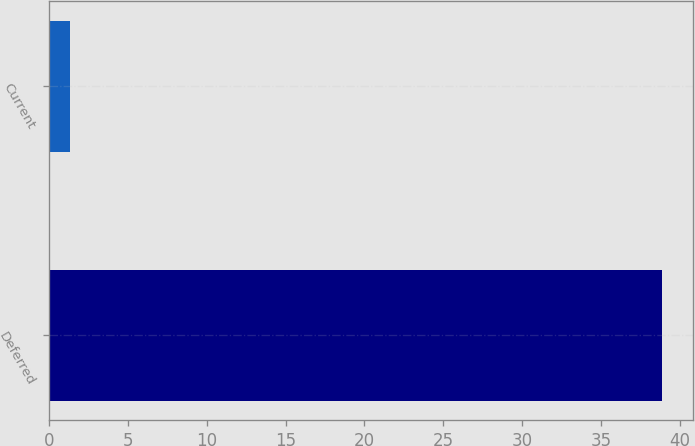Convert chart to OTSL. <chart><loc_0><loc_0><loc_500><loc_500><bar_chart><fcel>Deferred<fcel>Current<nl><fcel>38.9<fcel>1.3<nl></chart> 